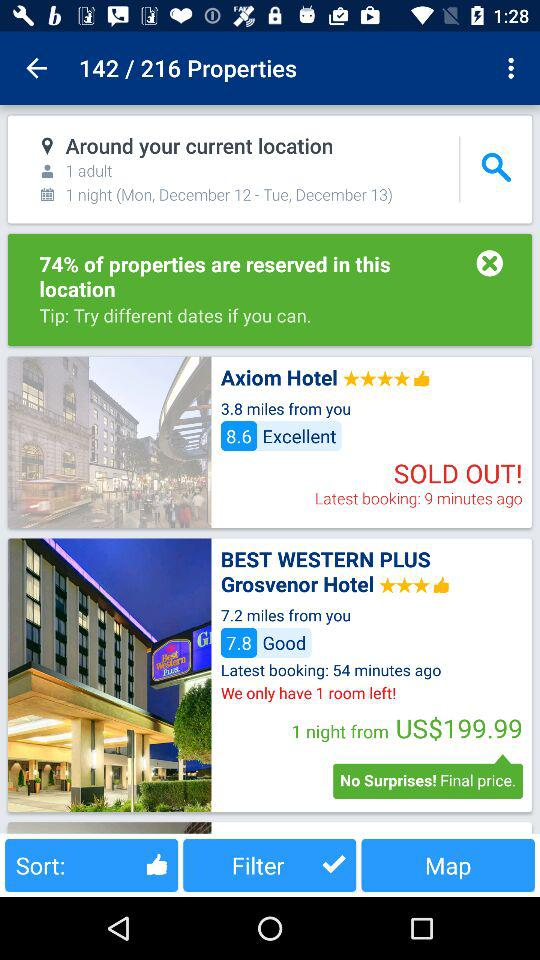How many rooms are left at the "Best Western Plus Grosvenor Hotel"? There is 1 room left at the "Best Western Plus Grosvenor Hotel". 